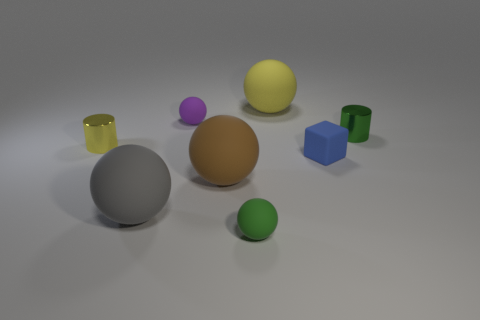Subtract all big yellow spheres. How many spheres are left? 4 Subtract all cubes. How many objects are left? 7 Subtract all green balls. How many balls are left? 4 Add 2 tiny blue matte cubes. How many objects exist? 10 Add 5 green things. How many green things exist? 7 Subtract 0 gray cylinders. How many objects are left? 8 Subtract 1 blocks. How many blocks are left? 0 Subtract all red spheres. Subtract all purple cylinders. How many spheres are left? 5 Subtract all red cylinders. How many cyan blocks are left? 0 Subtract all blue cubes. Subtract all green objects. How many objects are left? 5 